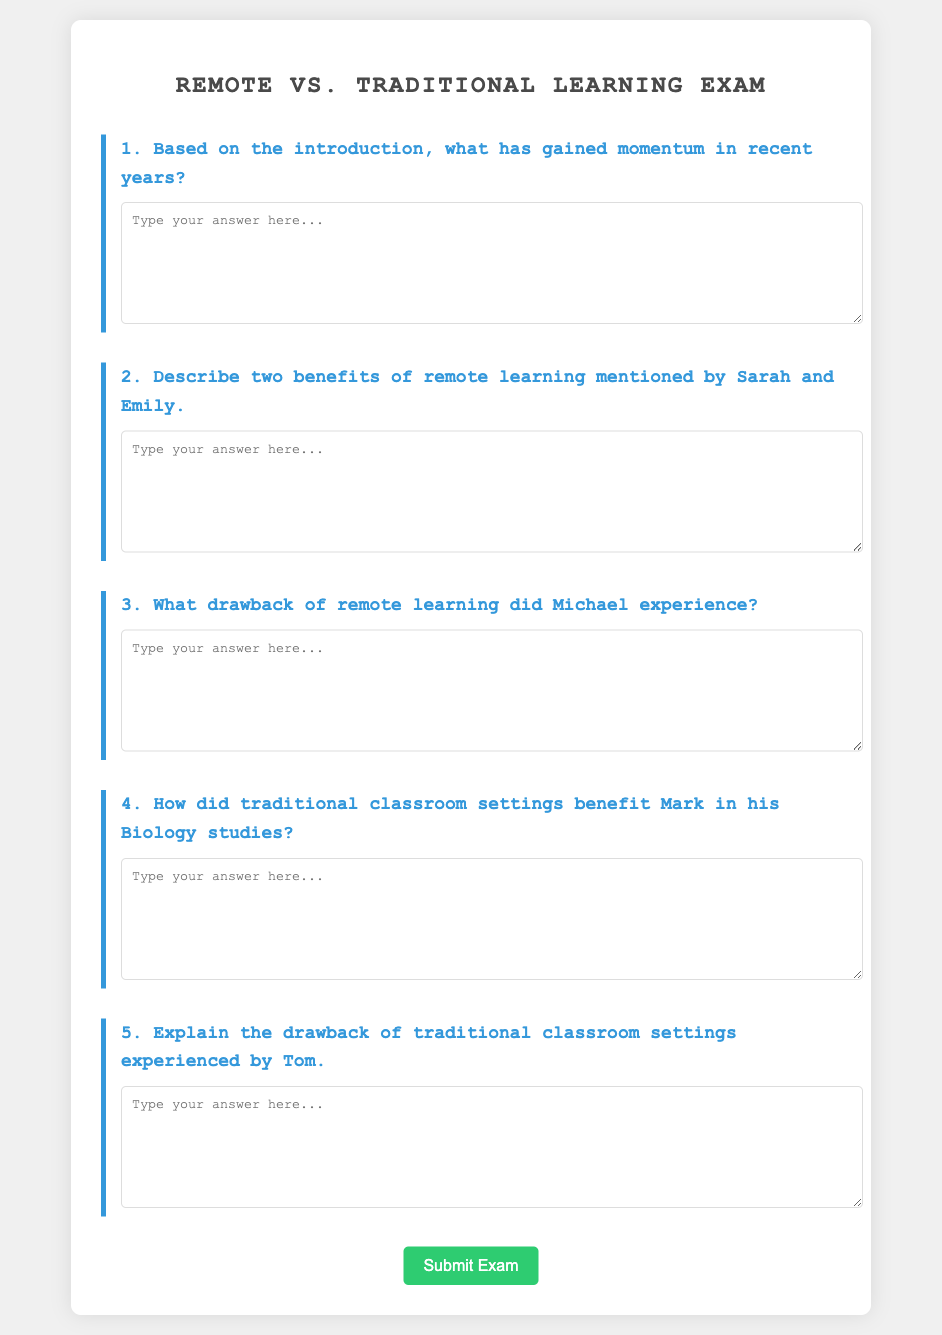What has gained momentum in recent years? The introduction likely discusses the increase in popularity or adoption of a specific educational approach or method, specifically pointing to remote learning as a trend.
Answer: Remote learning What are two benefits of remote learning mentioned by Sarah and Emily? The document specifies certain advantages of remote learning as expressed by named individuals, indicating that both Sarah and Emily highlighted some beneficial aspects.
Answer: Flexibility, accessibility What drawback of remote learning did Michael experience? The document mentions a specific issue or disadvantage related to remote learning that Michael faced, which indicates one of the challenges of this learning method.
Answer: Isolation How did traditional classroom settings benefit Mark in his Biology studies? The document illustrates how Mark's engagement in traditional settings provided him with certain advantages in understanding or learning Biology, indicating a positive impact.
Answer: Interaction with peers What is the drawback of traditional classroom settings experienced by Tom? The document outlines a specific challenge or downside of traditional classroom environments as faced by Tom, highlighting an area where these environments may fall short.
Answer: Commuting time 